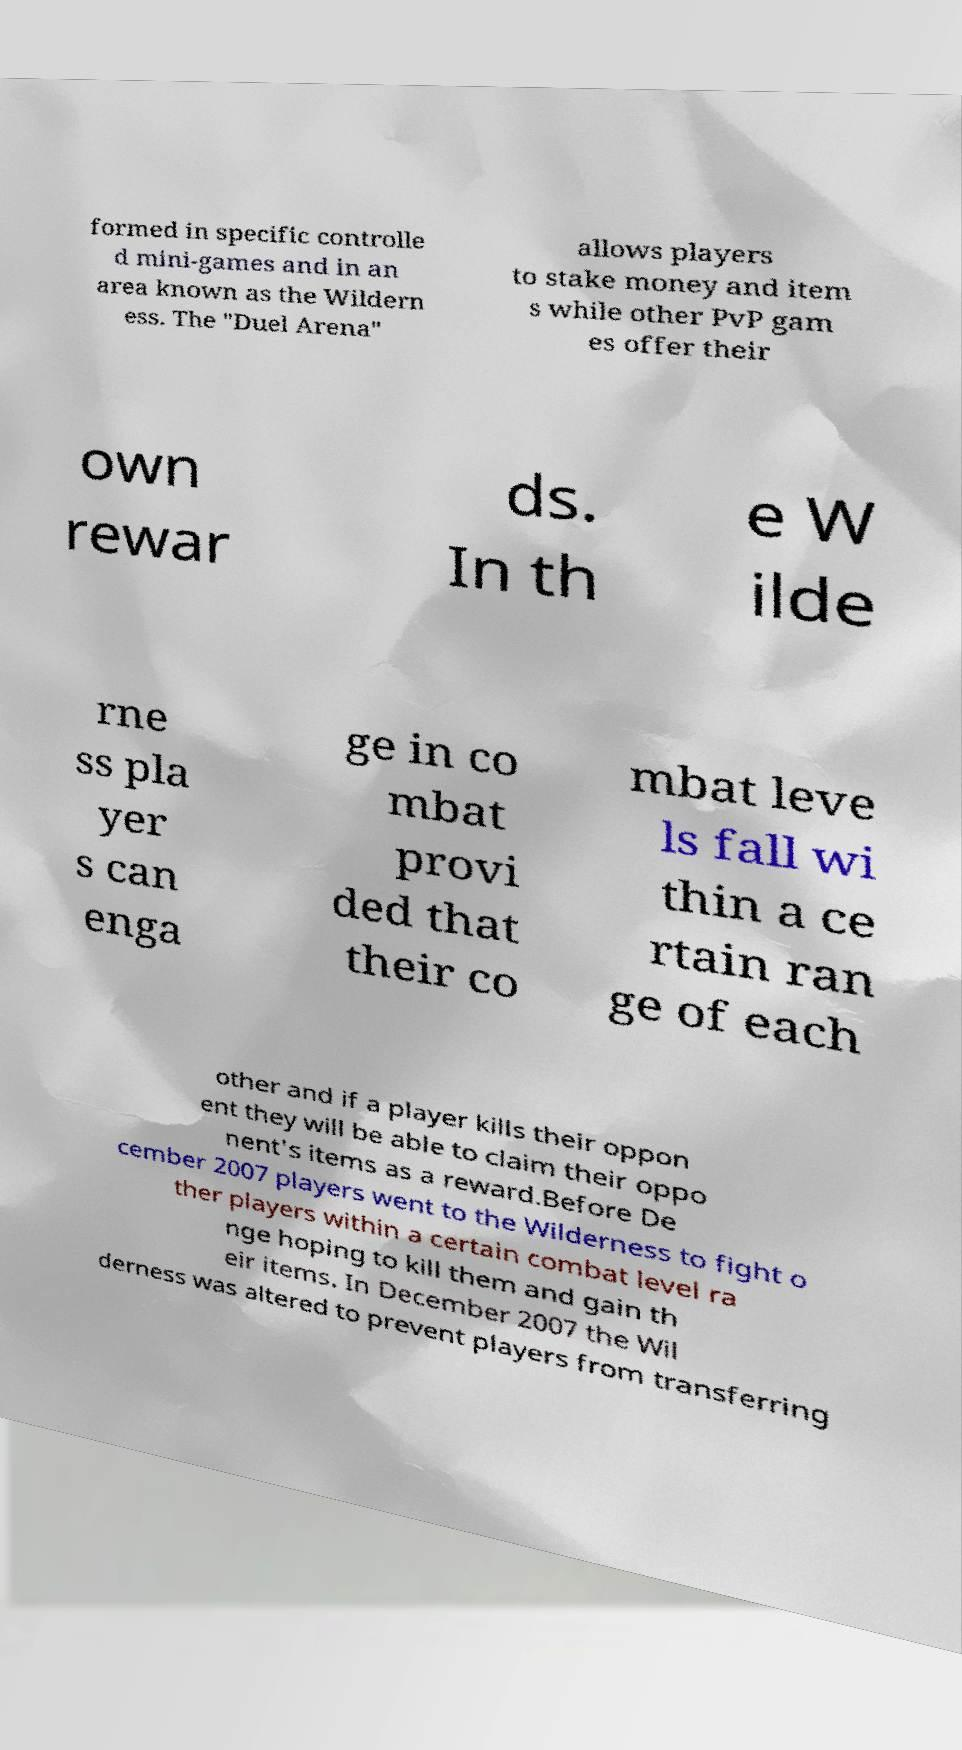Could you extract and type out the text from this image? formed in specific controlle d mini-games and in an area known as the Wildern ess. The "Duel Arena" allows players to stake money and item s while other PvP gam es offer their own rewar ds. In th e W ilde rne ss pla yer s can enga ge in co mbat provi ded that their co mbat leve ls fall wi thin a ce rtain ran ge of each other and if a player kills their oppon ent they will be able to claim their oppo nent's items as a reward.Before De cember 2007 players went to the Wilderness to fight o ther players within a certain combat level ra nge hoping to kill them and gain th eir items. In December 2007 the Wil derness was altered to prevent players from transferring 